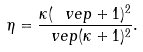<formula> <loc_0><loc_0><loc_500><loc_500>\eta = \frac { \kappa ( \ v e p + 1 ) ^ { 2 } } { \ v e p ( \kappa + 1 ) ^ { 2 } } .</formula> 